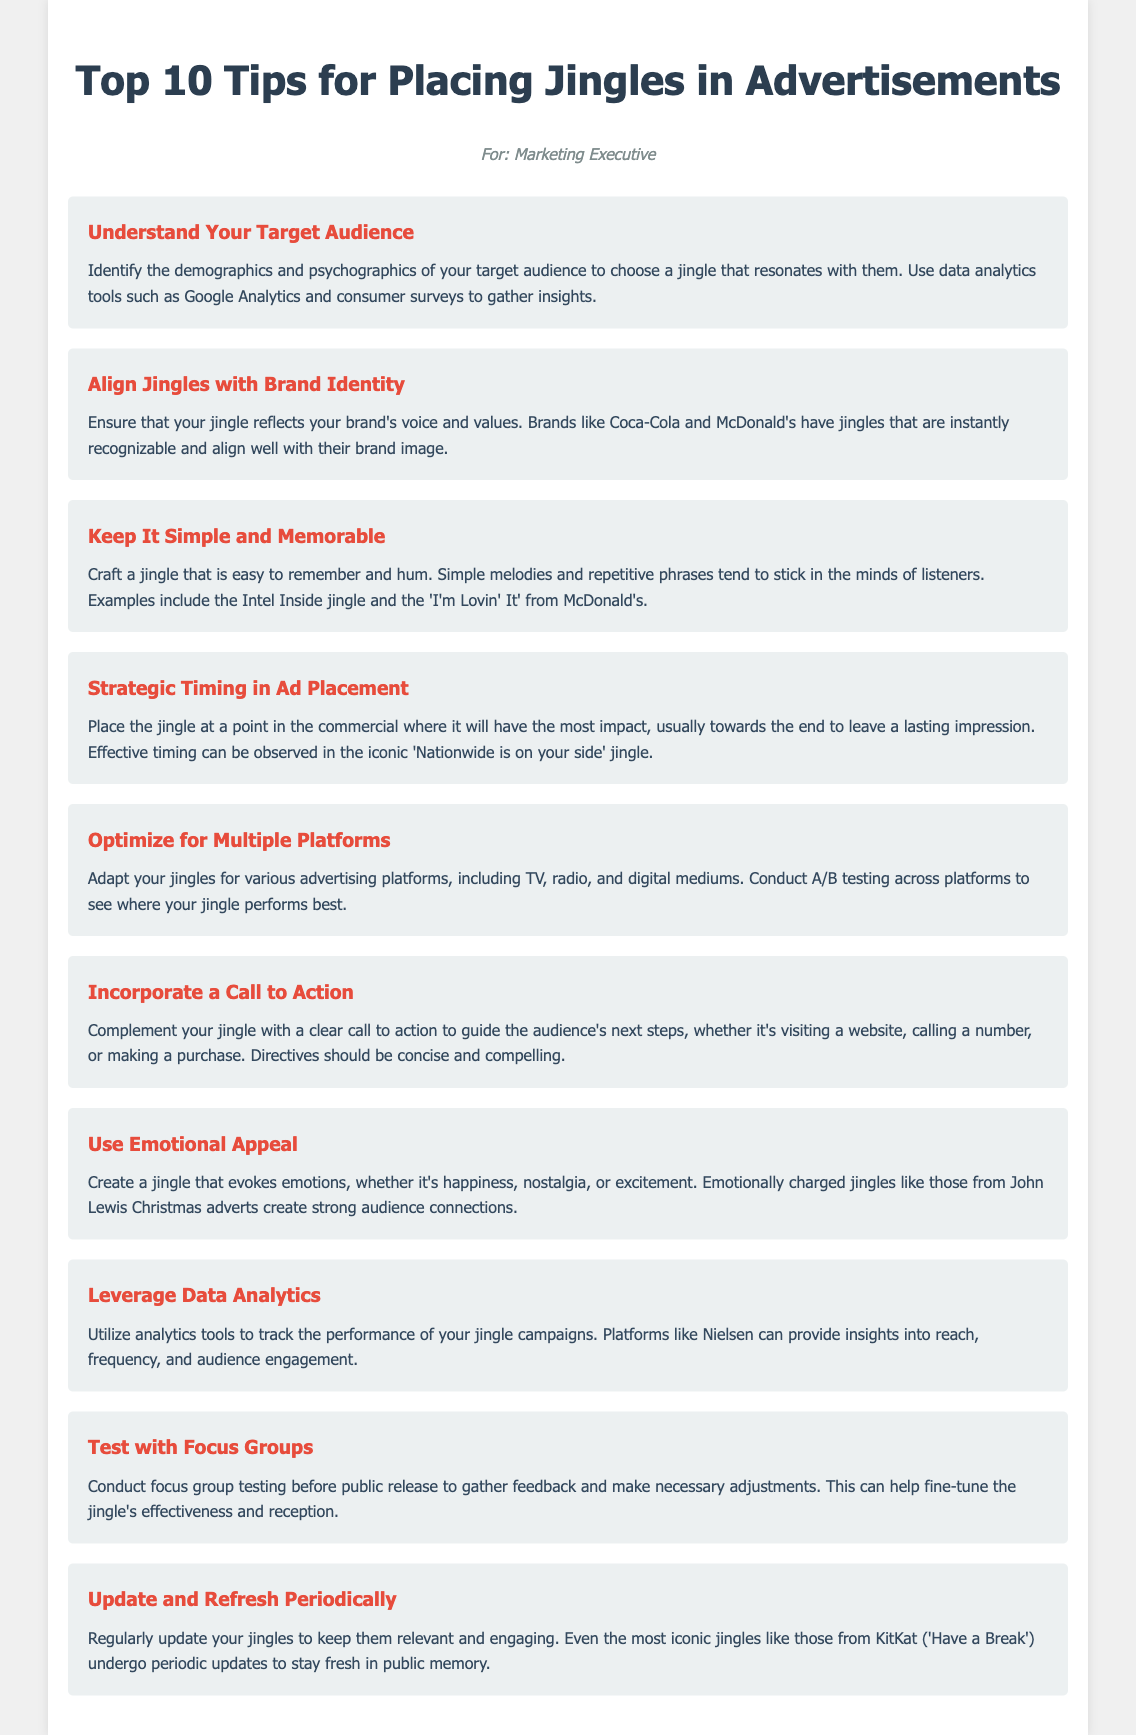what is the title of the document? The title of the document is a key piece of information found in the header section.
Answer: Top 10 Tips for Placing Jingles in Advertisements how many tips are listed in the document? The number of tips can be counted from the ordered list presented in the document.
Answer: 10 which brand is mentioned as having a recognizable jingle? The document provides examples of brands with noticeable jingles in the second tip.
Answer: Coca-Cola what should jingles evoke according to the document? The document emphasizes emotional engagement in the seventh tip, indicating what feelings jingles should inspire.
Answer: emotions what type of testing is recommended before public release? The document suggests a particular method of evaluation in the ninth tip, which involves gathering feedback on the jingle.
Answer: focus group testing what is a key element to include with a jingle? The document highlights an essential component that should accompany jingles in the sixth tip.
Answer: call to action which jingle is mentioned in reference to effective timing? The reference to effective timing can be found in the fourth tip, providing a well-known example.
Answer: Nationwide is on your side what should you regularly do to jingles according to the document? The last tip advises a particular action to maintain relevance in jingle marketing.
Answer: update and refresh which tools are suggested for tracking jingle performance? The document mentions analytics tools for monitoring jingle campaigns in the eighth tip.
Answer: Nielsen 